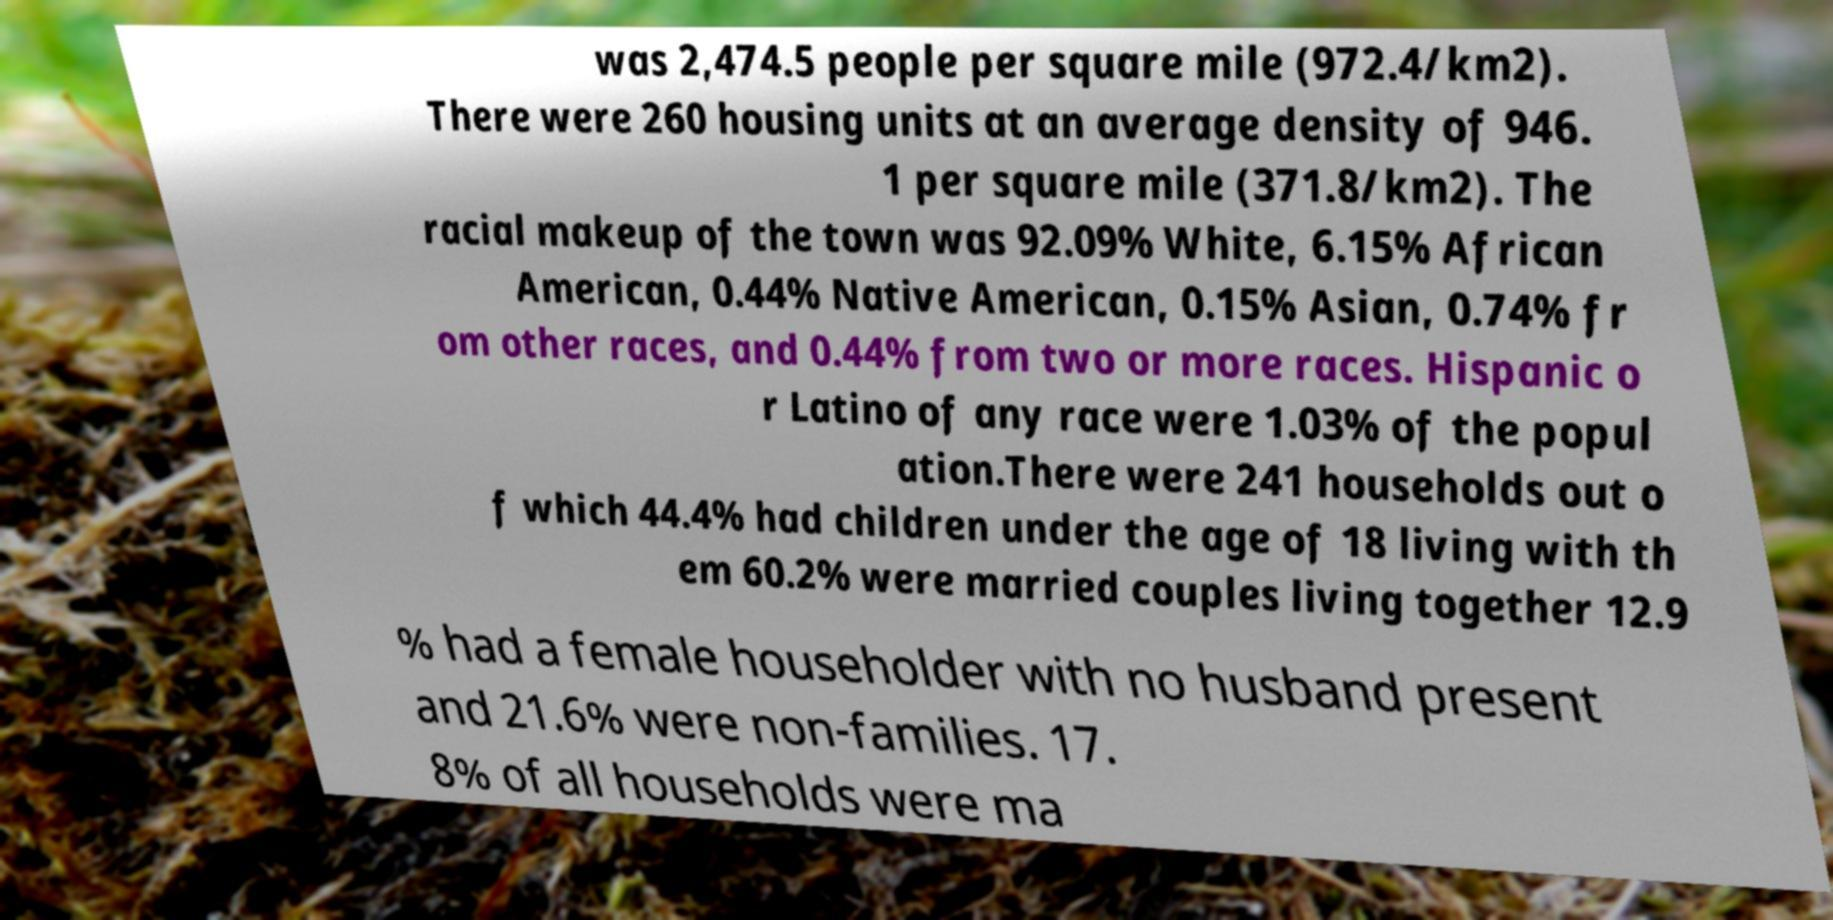Can you accurately transcribe the text from the provided image for me? was 2,474.5 people per square mile (972.4/km2). There were 260 housing units at an average density of 946. 1 per square mile (371.8/km2). The racial makeup of the town was 92.09% White, 6.15% African American, 0.44% Native American, 0.15% Asian, 0.74% fr om other races, and 0.44% from two or more races. Hispanic o r Latino of any race were 1.03% of the popul ation.There were 241 households out o f which 44.4% had children under the age of 18 living with th em 60.2% were married couples living together 12.9 % had a female householder with no husband present and 21.6% were non-families. 17. 8% of all households were ma 